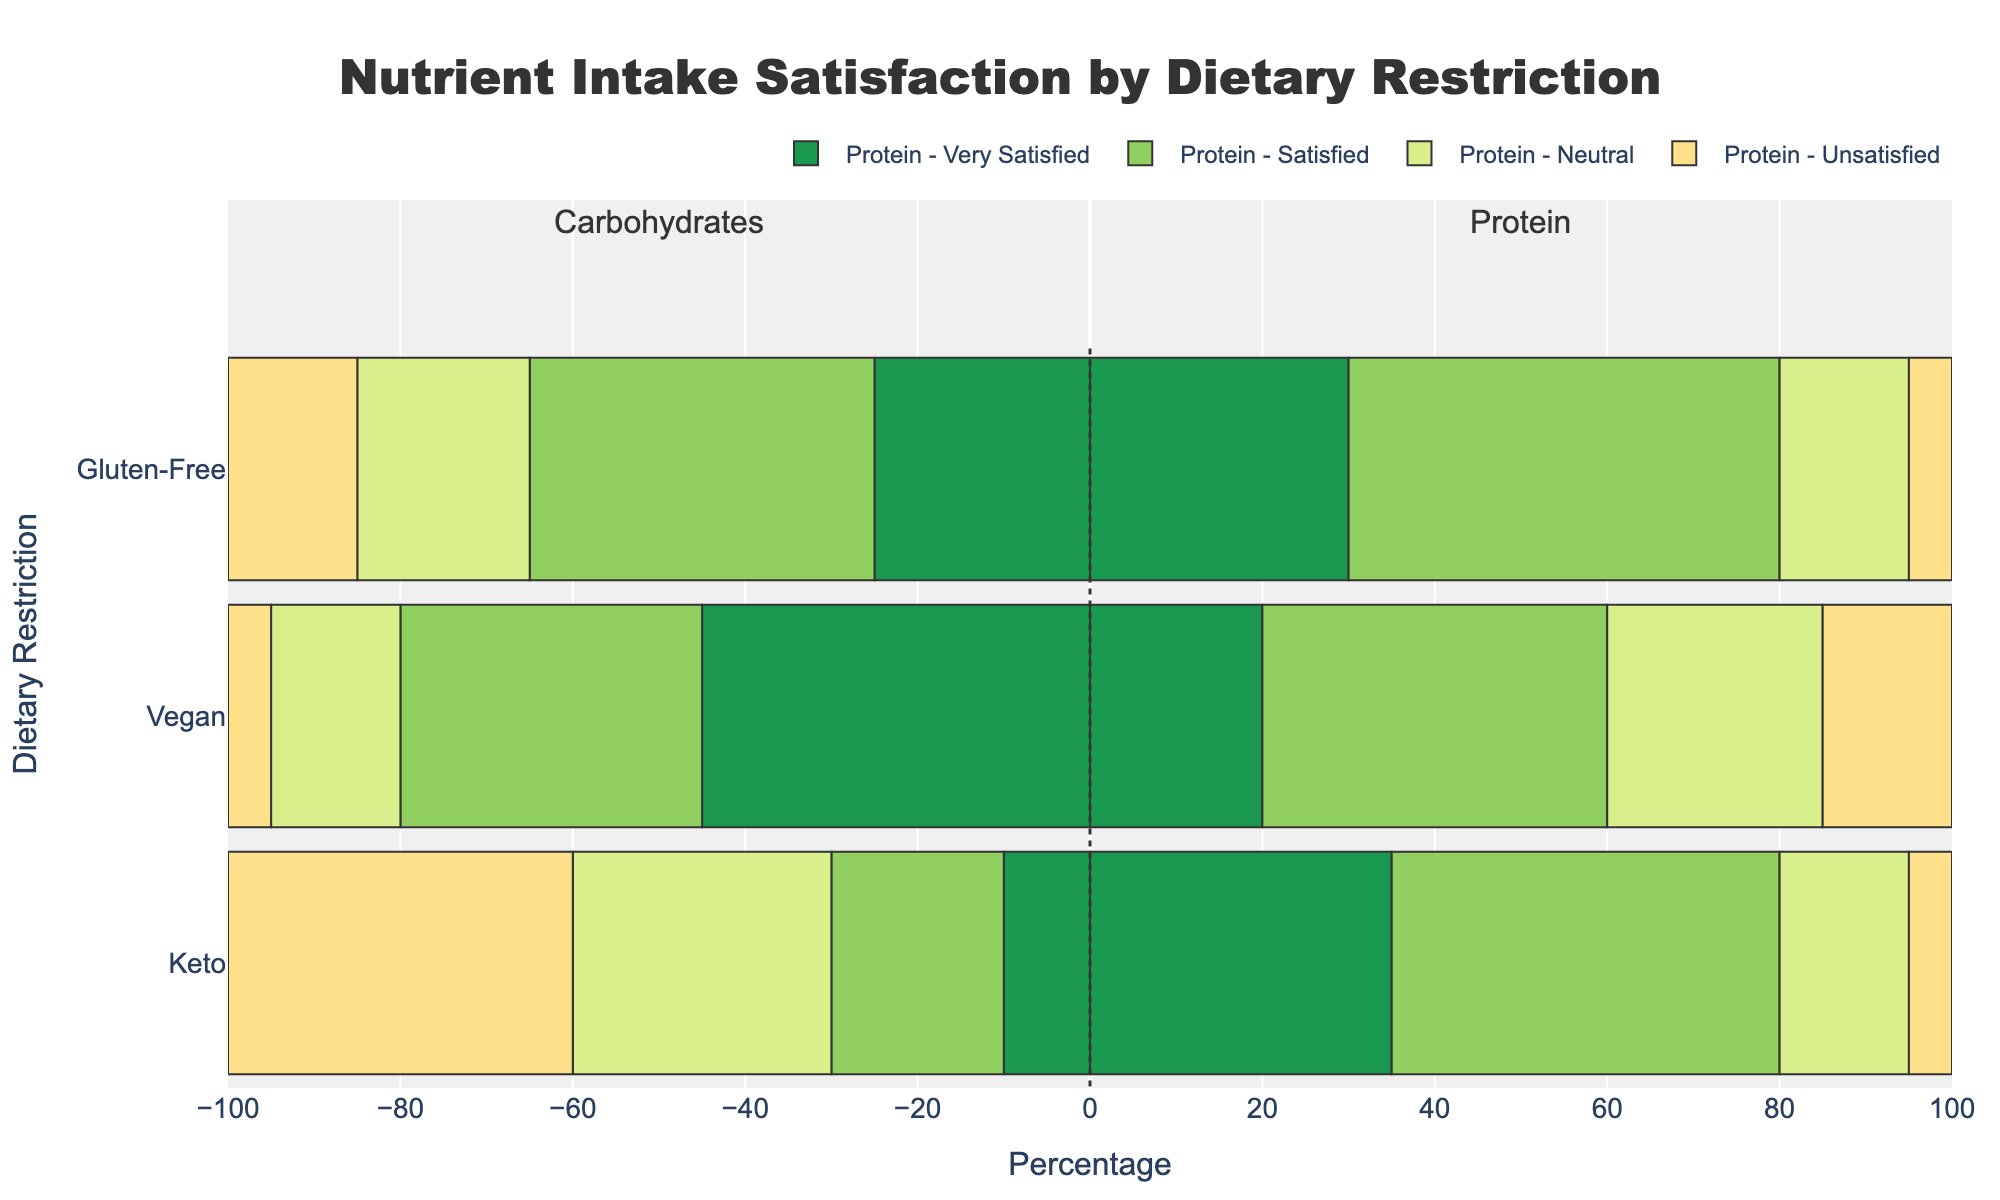What is the satisfaction level with protein intake among Keto diet followers? Look at the bar segments for "Keto" and "Protein”. Very Satisfied is 35%, Satisfied is 45%, Neutral is 15%, and Unsatisfied is 5%.
Answer: Very Satisfied: 35%, Satisfied: 45%, Neutral: 15%, Unsatisfied: 5% Which dietary restriction has the highest percentage of "Very Satisfied" with carbohydrate intake? Compare the "Very Satisfied" segments for "Carbohydrates" across Keto, Vegan, and Gluten-Free. Vegan has the highest at 45%.
Answer: Vegan Between Keto and Vegan diets, which has a higher neutral satisfaction level for protein intake? Locate the "Neutral" segments for protein under Keto and Vegan. Keto has 15%, Vegan has 25%. Thus, Vegan is higher.
Answer: Vegan How does the percentage of “Satisfied” with carbohydrates intake compare between Vegan and Gluten-Free diets? Find and compare the "Satisfied" segments for carbohydrates. Vegan shows 35%, Gluten-Free shows 40%. Gluten-Free is higher.
Answer: Gluten-Free What proportion of Vegan diet followers are at least satisfied (including "Very Satisfied" and "Satisfied") with their carbohydrate intake? Sum the "Very Satisfied" and "Satisfied" percentages for Vegan carbohydrates: 45% + 35% = 80%.
Answer: 80% What is the difference between the “Very Satisfied” protein intake percentages of Keto and Gluten-Free diet followers? Compare the "Very Satisfied" segments for protein under Keto (35%) and Gluten-Free (30%). The difference is 35% - 30%.
Answer: 5% How does the satisfaction level for carbohydrate intake among Gluten-Free diets compare visually to that of the Keto diet? Observe the height/length of the bars for "Carbohydrates" under both Gluten-Free and Keto. The Gluten-Free “Satisfied” bar is longer than Keto's “Satisfied” bar and overall, Gluten-Free has longer “Satisfied” and “Very Satisfied” bars than Keto, which has longer “Neutral” and “Unsatisfied” bars.
Answer: Gluten-Free has higher satisfaction What percentage of Keto diet followers are “Unsatisfied” with their carbohydrate intake? Look at the "Unsatisfied" segment for carbohydrates in the Keto bar. The percentage is 40%.
Answer: 40% What is the comparison in the overall satisfaction (including "Very Satisfied" and "Satisfied") with protein intake between Keto and Gluten-Free diets? Sum the "Very Satisfied" and "Satisfied" percentages for both diets: Keto (35% + 45%) = 80%, Gluten-Free (30% + 50%) = 80%. Both have identical satisfaction levels.
Answer: Equal 